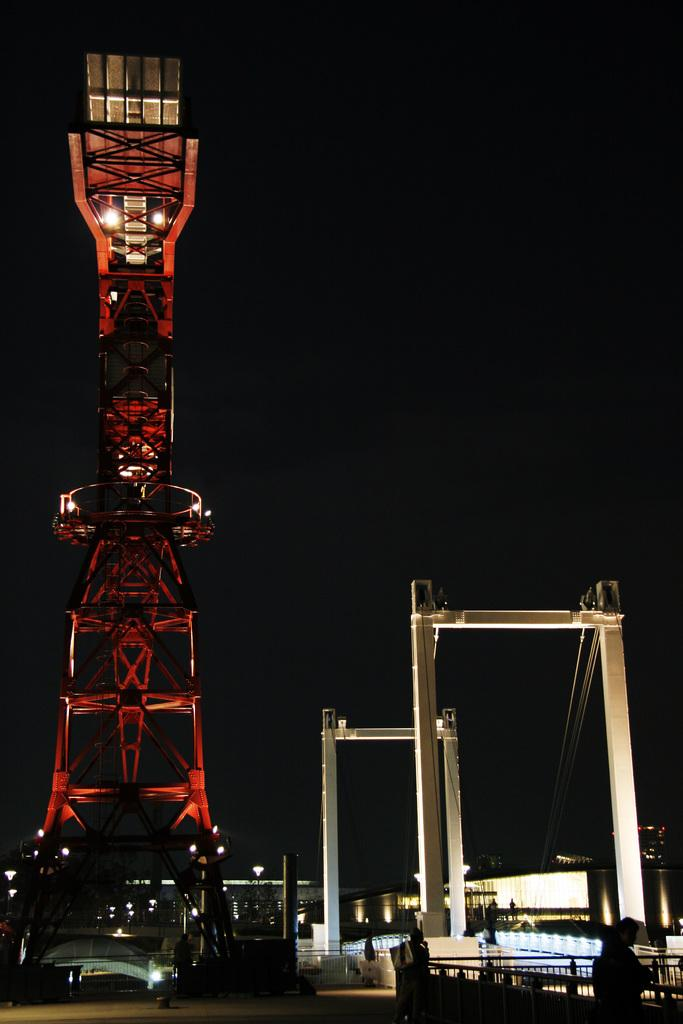What structure is the main focus of the image? There is a tower in the image. What other architectural feature can be seen in the image? There is a bridge in the image. Where are the two persons located in the image? The two persons are standing near a railing in the bottom right of the image. What is the color of the background in the image? The background of the image is dark. What type of appliance can be seen being destroyed by the frogs in the image? There are no appliances or frogs present in the image. 